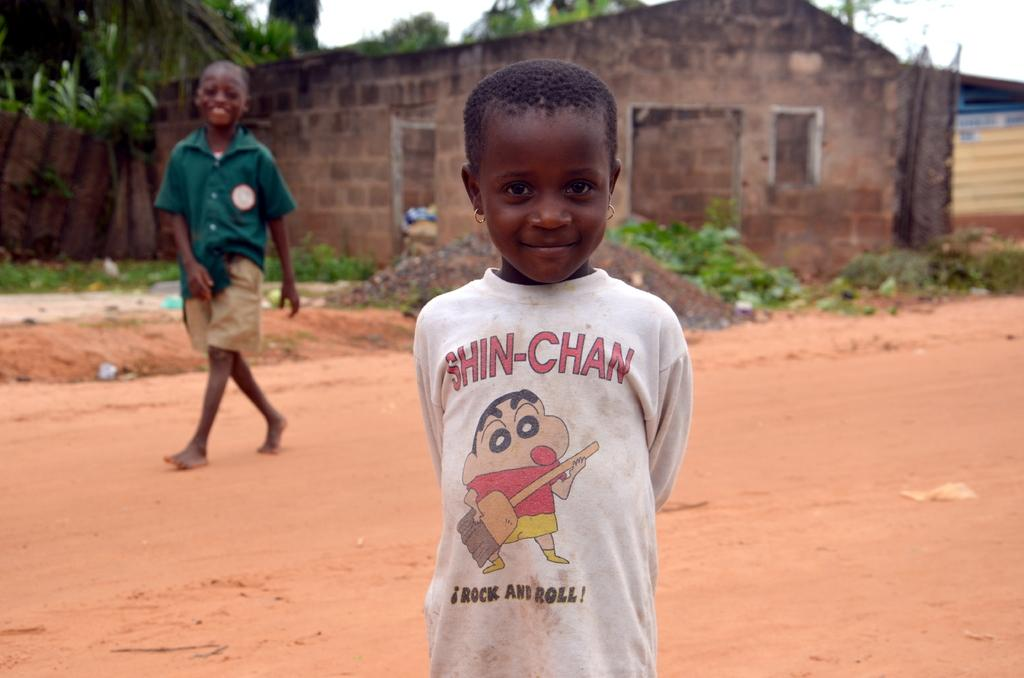What is the girl in the image wearing? The girl in the image is wearing a white t-shirt. Where is the girl positioned in the image? The girl is standing in the front. What is the boy in the image doing? The boy is walking on a red stone road. What can be seen in the background of the image? There are homes visible in the background, and trees are present behind the homes. What type of juice is the girl drinking in the image? There is no juice present in the image; the girl is wearing a white t-shirt and standing in the front. 